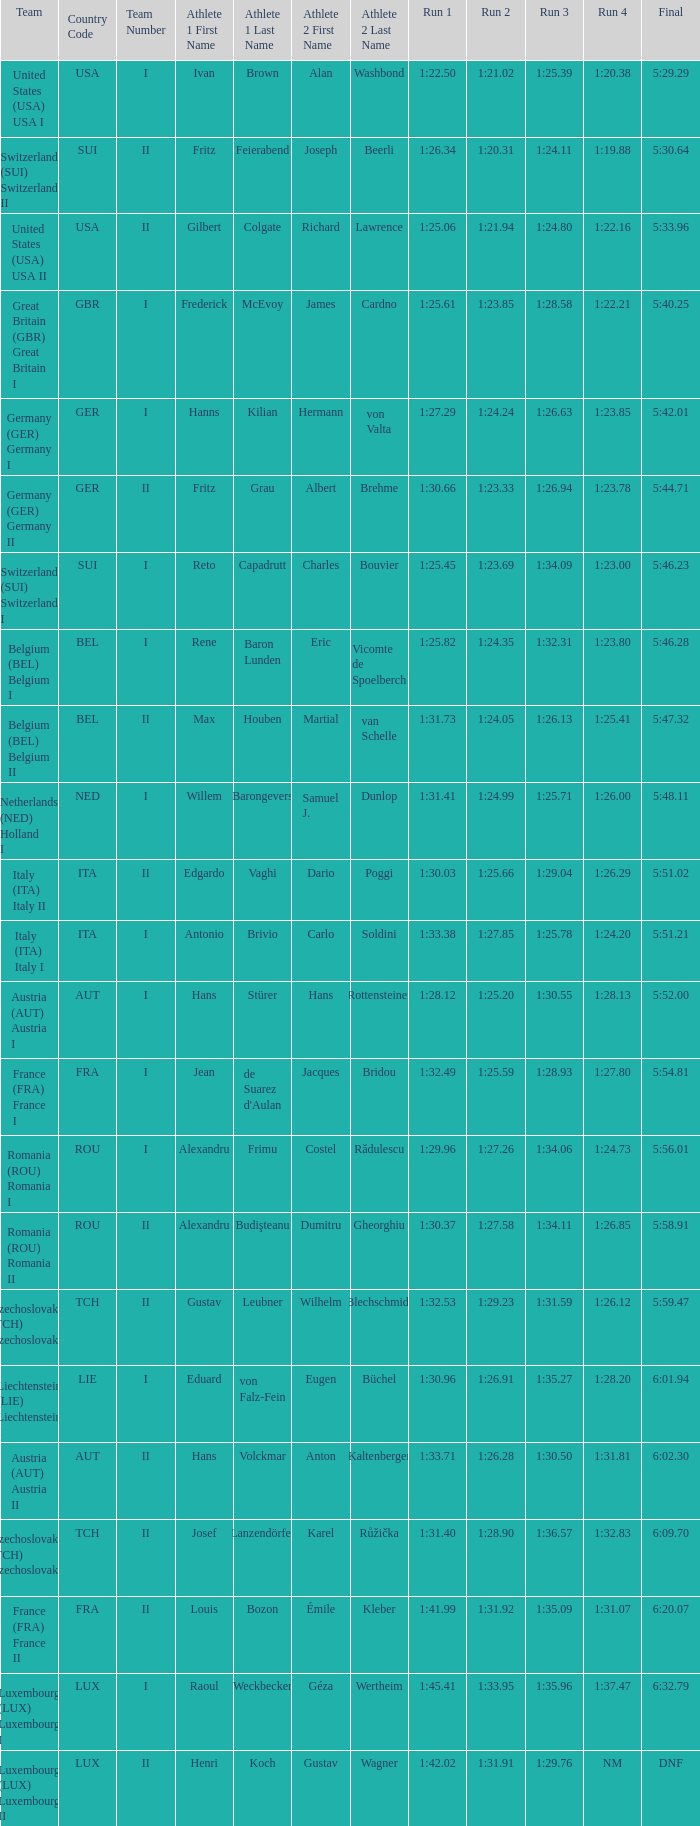Which run 2 has a run 1 time of 1:3 1:25.66. 